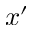Convert formula to latex. <formula><loc_0><loc_0><loc_500><loc_500>x ^ { \prime }</formula> 